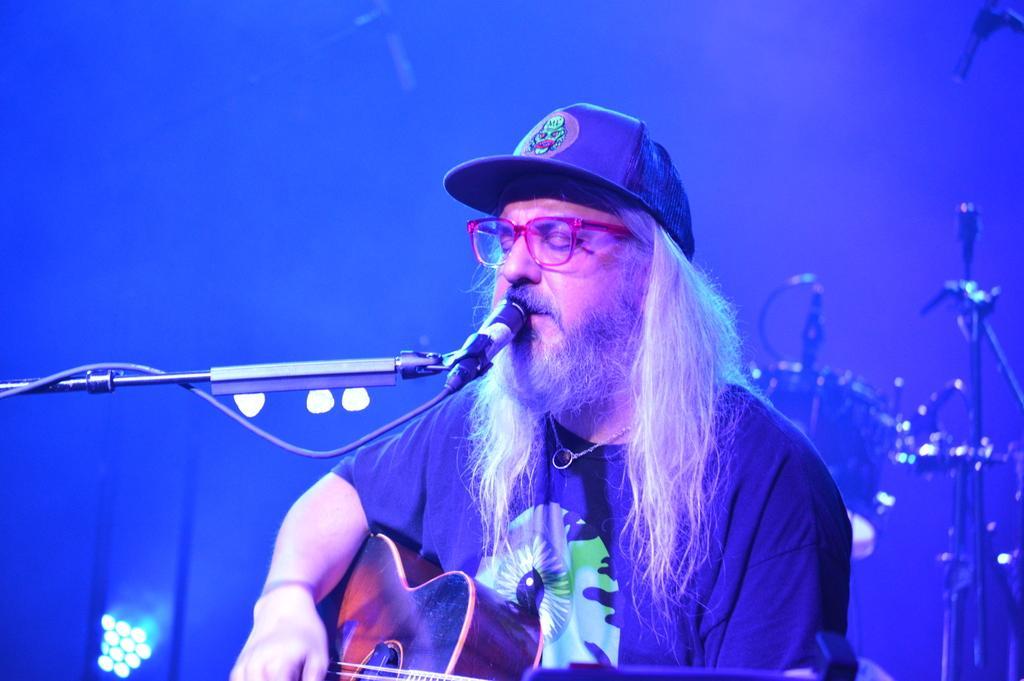Could you give a brief overview of what you see in this image? In this image there is a man who is playing the guitar with his hand and singing through the mic which is in front of him. At the back side there are lights and drums. 